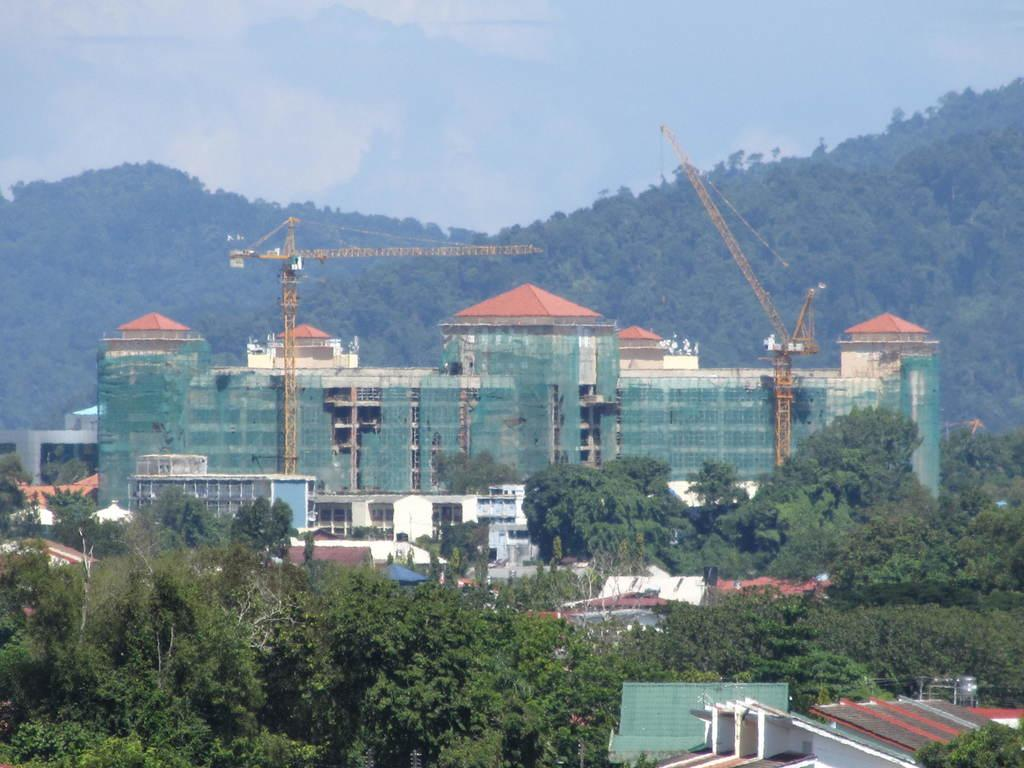What type of structures can be seen in the image? There are buildings and houses in the image. What natural elements are present in the image? There are trees and mountains covered with trees in the image. What type of construction equipment can be seen in the image? There are cranes in the image. What is visible in the sky in the image? There are clouds in the sky in the image. Where is the flock of pigs located in the image? There is no flock of pigs present in the image. What type of spark can be seen coming from the trees in the image? There is no spark present in the image; it features trees, mountains, clouds, and construction equipment. 